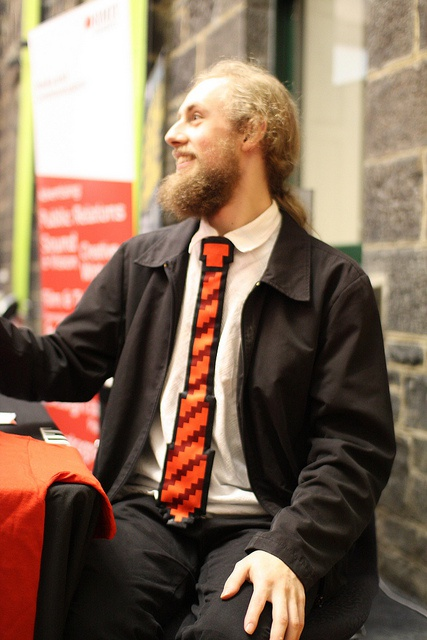Describe the objects in this image and their specific colors. I can see people in gray, black, maroon, and ivory tones, dining table in gray, black, maroon, and salmon tones, tie in gray, red, black, brown, and maroon tones, and chair in gray and black tones in this image. 